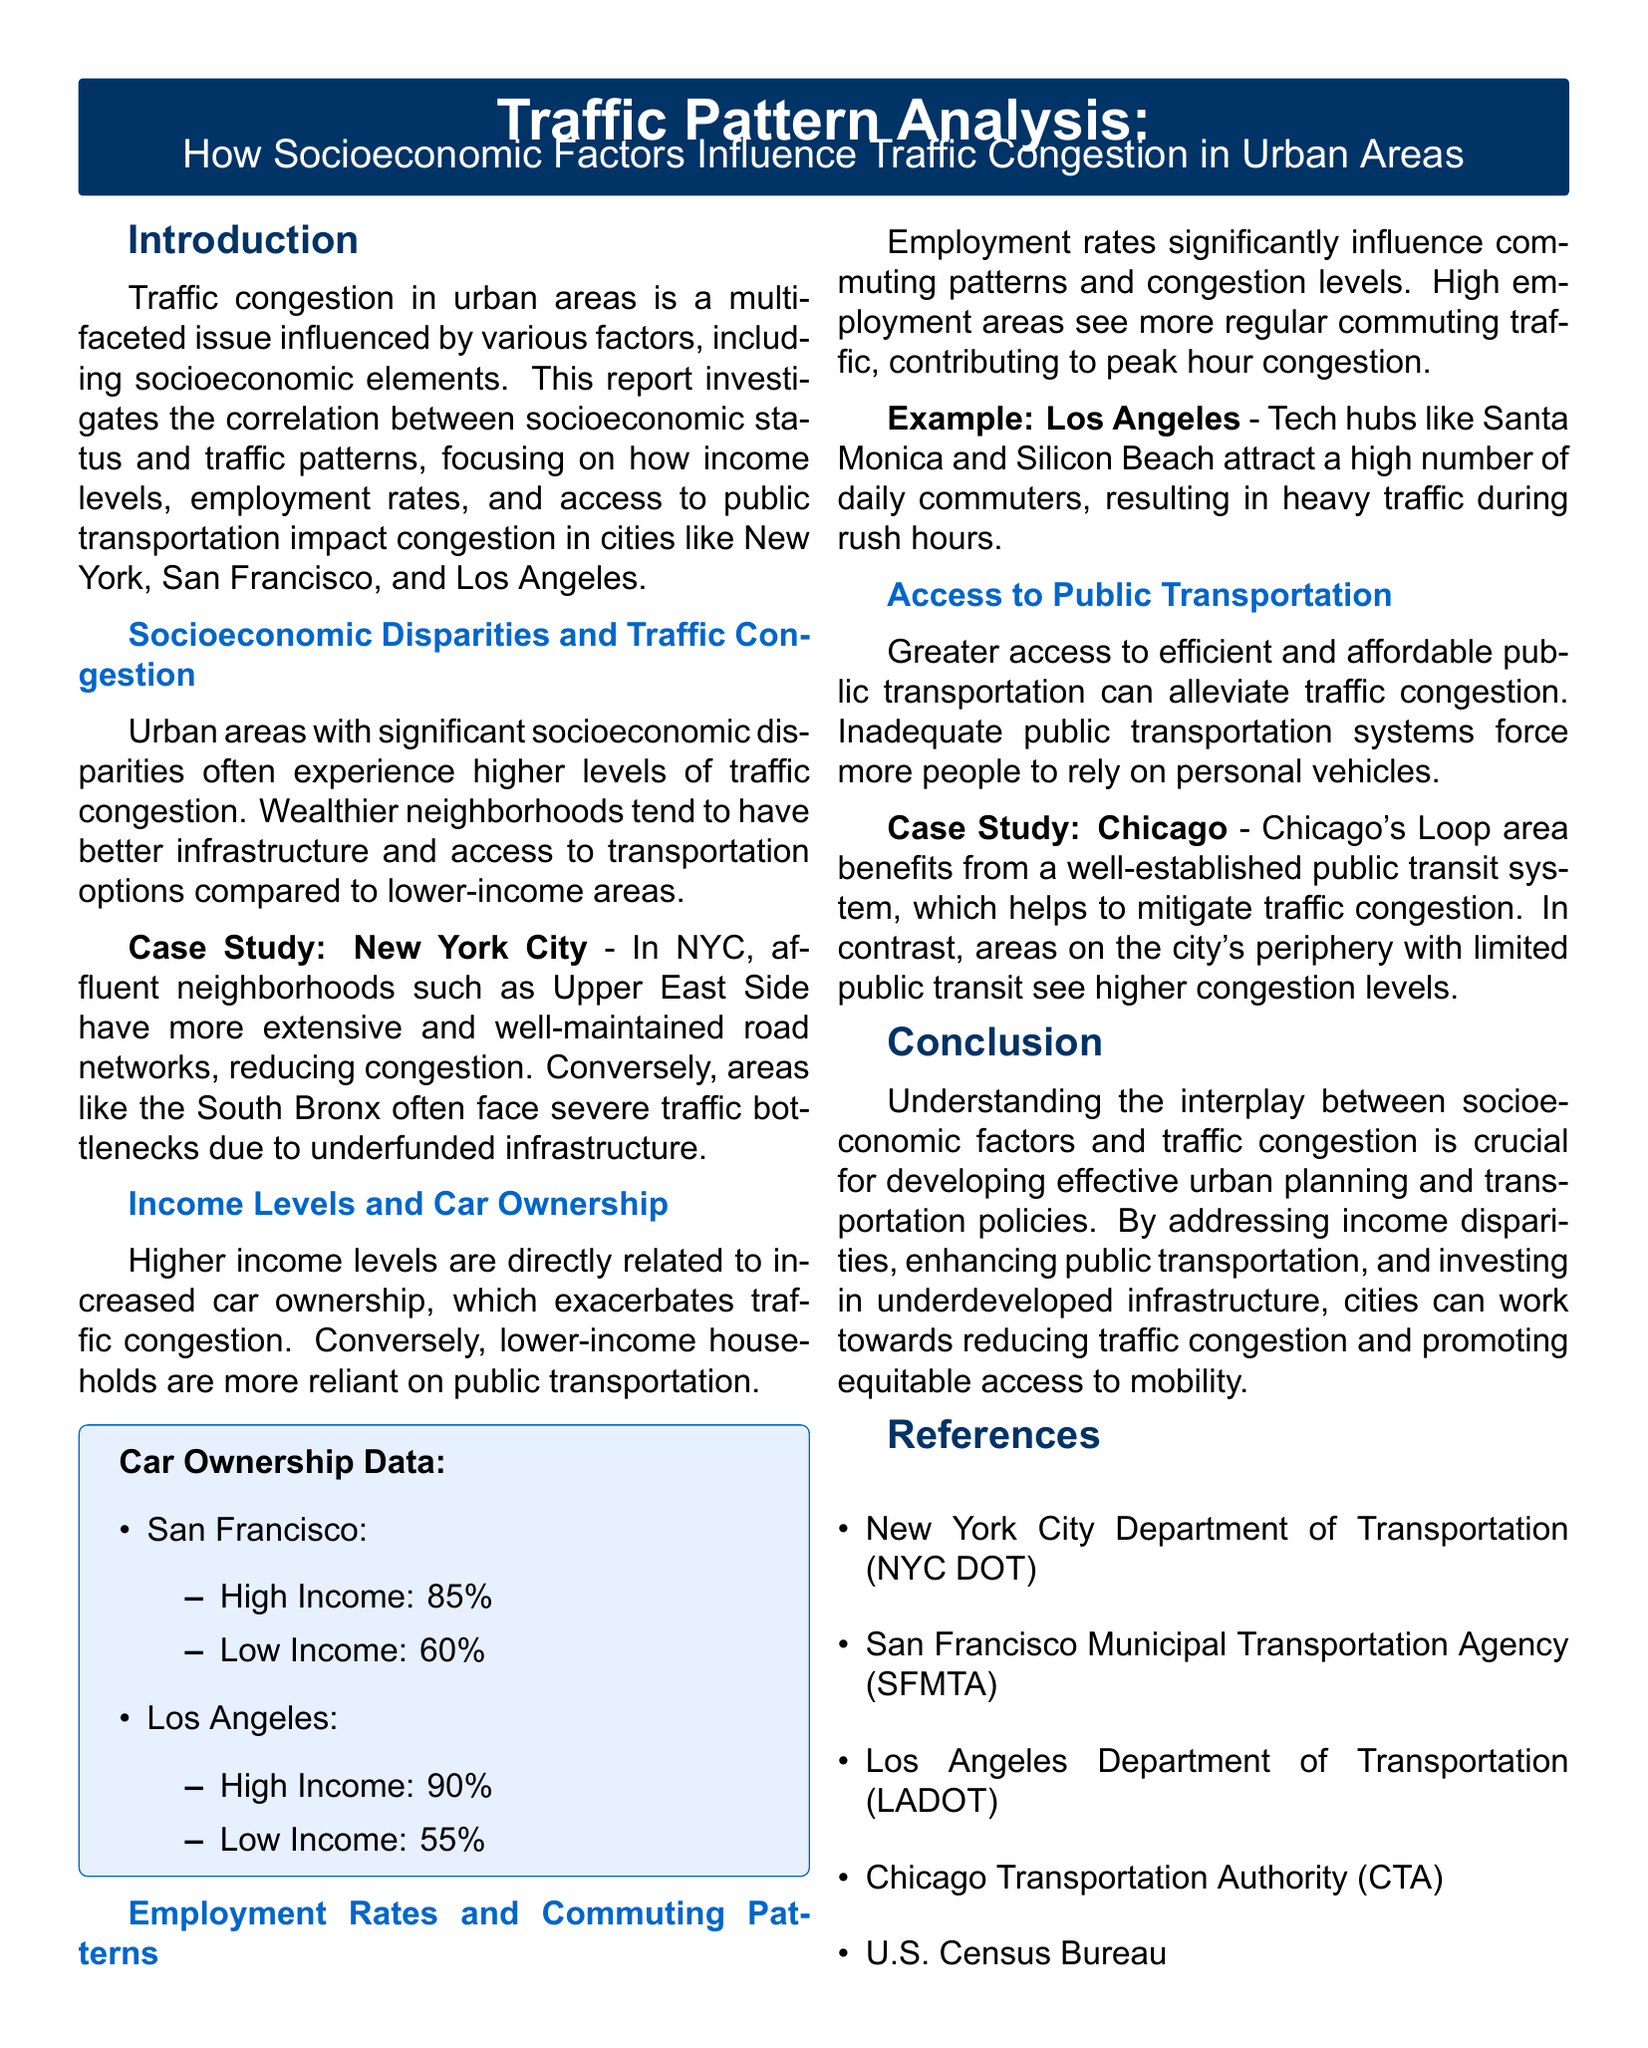What is the title of the report? The title of the report is prominently displayed at the beginning and summarizes the content related to traffic congestion and socioeconomic factors.
Answer: Traffic Pattern Analysis: How Socioeconomic Factors Influence Traffic Congestion in Urban Areas What case study is mentioned for New York City? The report discusses the traffic conditions in specific neighborhoods of New York City to illustrate socioeconomic influences, highlighting disparities in infrastructure.
Answer: Upper East Side and South Bronx What percentage of high-income households in San Francisco own cars? The document includes a specific percentage related to car ownership among different income levels in San Francisco.
Answer: 85% Which urban area benefits from a well-established public transit system? The report identifies urban areas with effective public transport and their impact on traffic conditions, specifically naming Chicago.
Answer: Chicago What socioeconomic factor is linked to increased car ownership? The report explicitly connects levels of income to vehicle ownership, explaining how these factors contribute to traffic congestion.
Answer: Income levels What two factors contribute to higher traffic congestion in low-income areas? The document discusses how infrastructure and access to public transportation are critical in understanding the congestion dynamics in urban settings.
Answer: Infrastructure and public transportation What is a significant consequence of high employment areas? The report states that areas with high employment experience certain outcomes that contribute to increased traffic during specific times of the day.
Answer: Peak hour congestion What is the primary conclusion drawn in the report? The report culminates in a summary that highlights the importance of addressing socioeconomic factors in traffic management and urban planning.
Answer: Addressing income disparities 